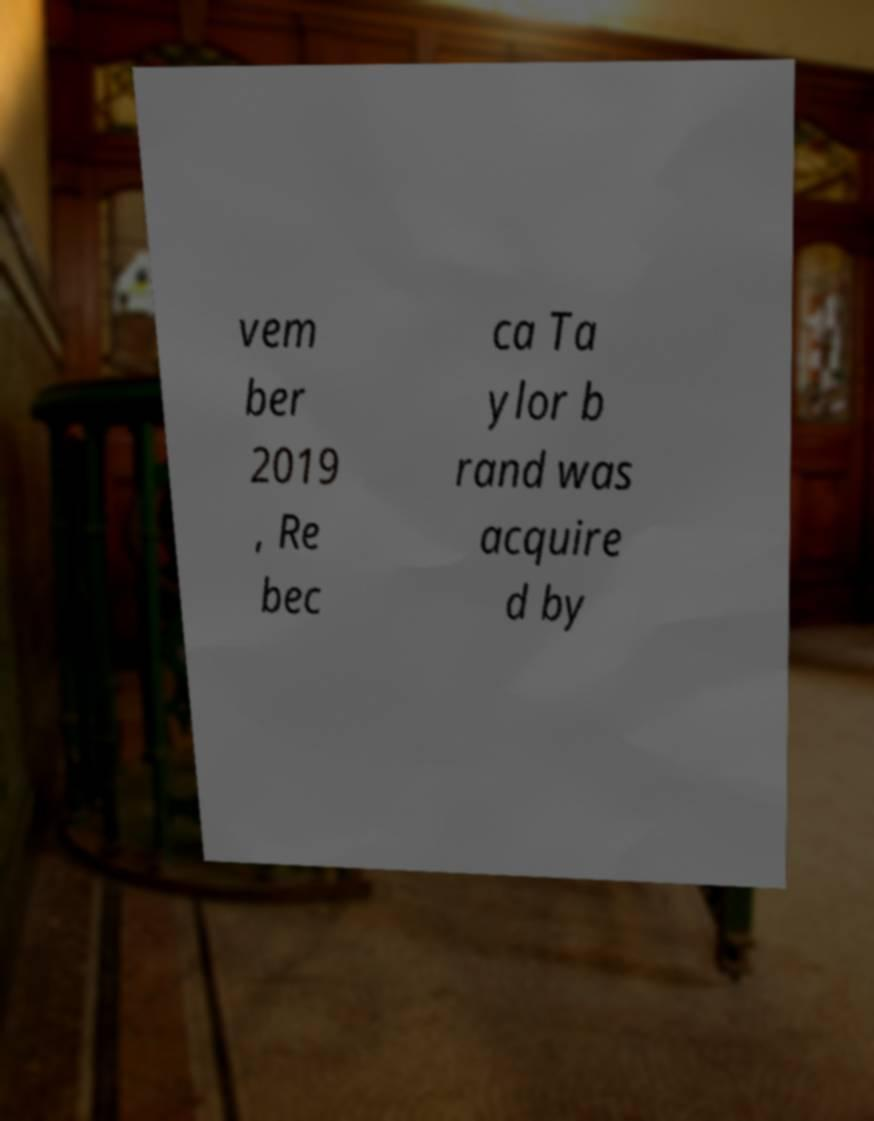For documentation purposes, I need the text within this image transcribed. Could you provide that? vem ber 2019 , Re bec ca Ta ylor b rand was acquire d by 